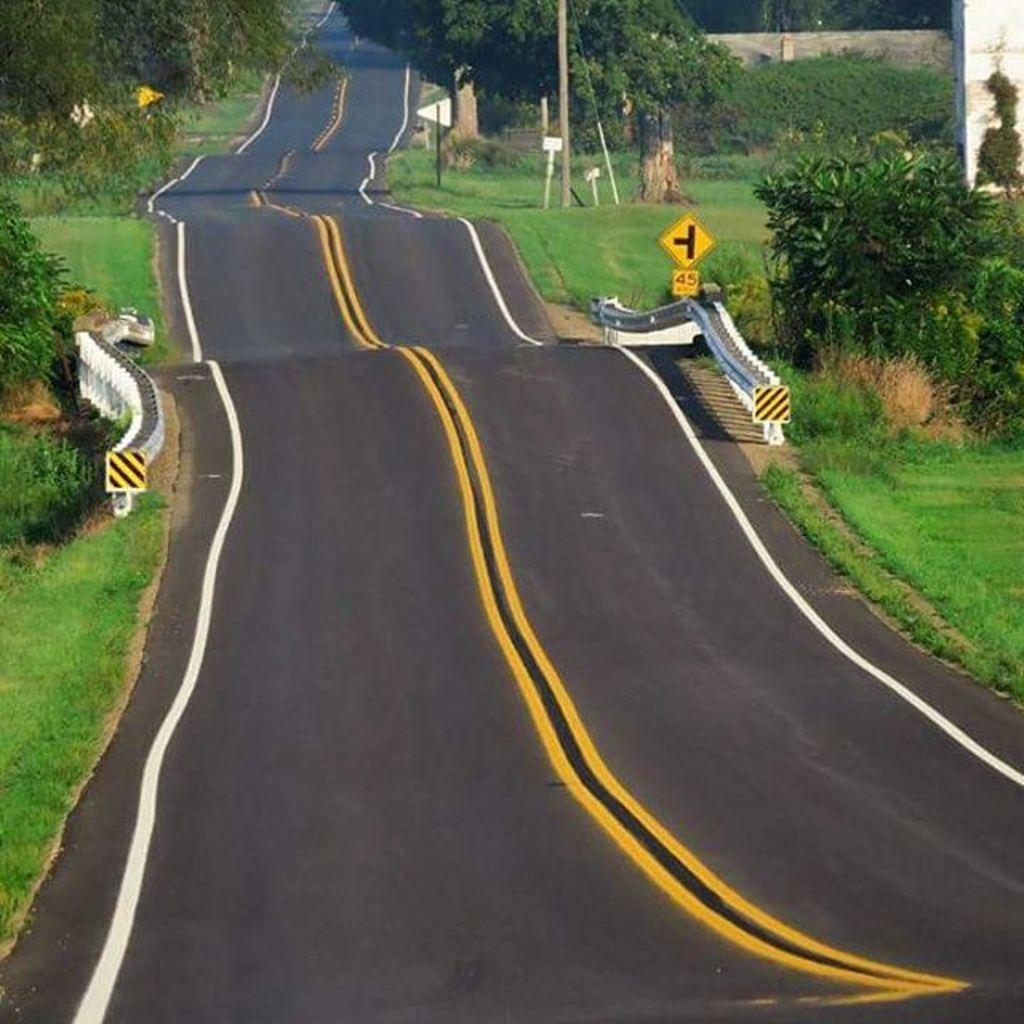What is the main feature in the center of the image? There is a road in the center of the image. What type of vegetation can be seen on both sides of the road? There is grass on both the right and left sides of the image. What structures are present in the image? Sign boards are present in the image. What can be seen in the distance in the image? There are trees in the background of the image. How many chickens are visible in the wilderness in the image? There are no chickens or wilderness present in the image. 